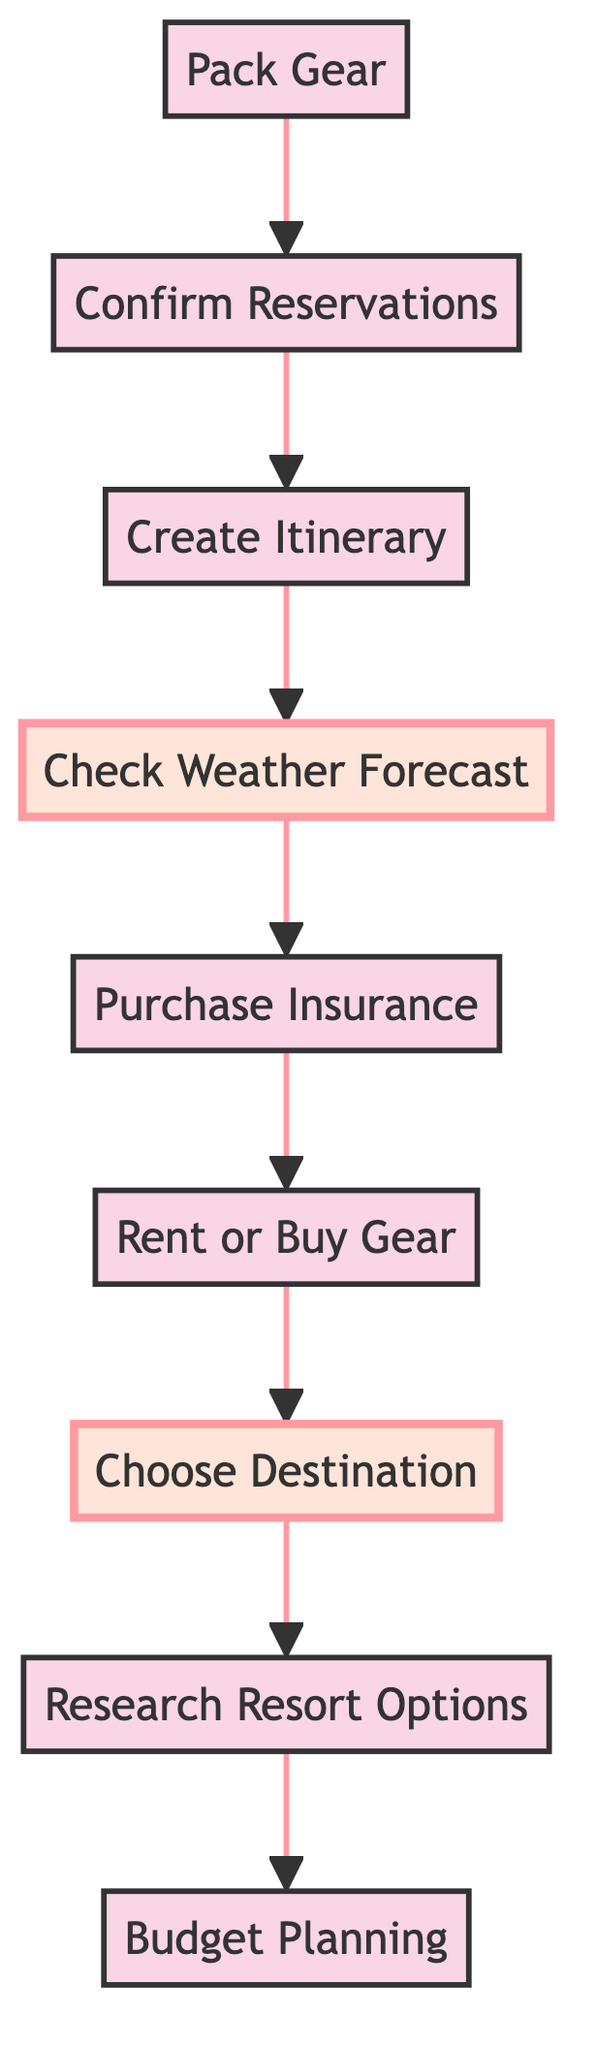How many nodes are in the diagram? The diagram consists of nine process nodes related to planning a snowboarding trip: Budget Planning, Research Resort Options, Choose Destination, Rent or Buy Gear, Purchase Insurance, Check Weather Forecast, Create Itinerary, Confirm Reservations, and Pack Gear. Counting these gives a total of nine nodes.
Answer: 9 What is the first step in the process? The first step in the flowchart, moving from the bottom to the top, is Budget Planning, as it is the lowest node that initiates the process.
Answer: Budget Planning Which node follows 'Confirm Reservations'? 'Confirm Reservations' is directly followed by 'Create Itinerary', according to the flow direction in the diagram.
Answer: Create Itinerary What is the last step before packing gear? The step directly preceding 'Pack Gear' is 'Confirm Reservations'; thus, it is the last step before packing the gear.
Answer: Confirm Reservations Which node is highlighted in the diagram? The highlighted nodes are 'Choose Destination' and 'Check Weather Forecast', as indicated by their distinctive formatting compared to the other nodes.
Answer: Choose Destination, Check Weather Forecast What nodes are interconnected directly with 'Rent or Buy Gear'? 'Rent or Buy Gear' has a direct connection to 'Purchase Insurance' and is preceded by 'Choose Destination', creating an incoming and an outgoing connection.
Answer: Purchase Insurance, Choose Destination At what stage do you check the weather forecast? You check the weather forecast after creating the itinerary, making this step crucial for planning your daily activities around the weather conditions.
Answer: After creating the itinerary Which step comes immediately after 'Choose Destination'? 'Choose Destination' is followed directly by 'Research Resort Options', indicating that after selecting a destination, the next logical step is to research available resorts.
Answer: Research Resort Options What is the purpose of the 'Purchase Insurance' node? The 'Purchase Insurance' node serves to ensure that the trip is safeguarded against accidents and equipment damage, acting as a precautionary measure during the planning process.
Answer: Cover accidents and equipment damage 